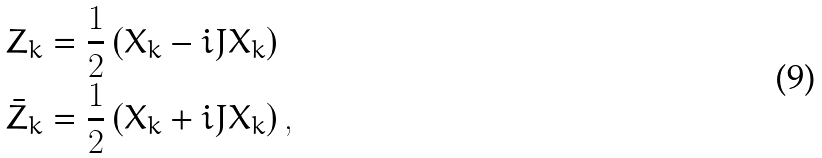Convert formula to latex. <formula><loc_0><loc_0><loc_500><loc_500>Z _ { k } & = \frac { 1 } { 2 } \left ( X _ { k } - i J X _ { k } \right ) \\ \bar { Z } _ { k } & = \frac { 1 } { 2 } \left ( X _ { k } + i J X _ { k } \right ) ,</formula> 